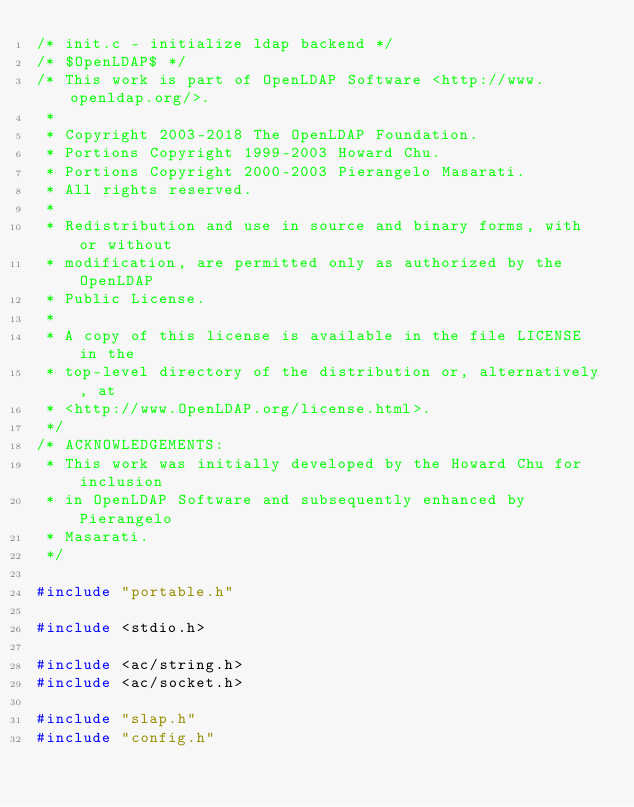Convert code to text. <code><loc_0><loc_0><loc_500><loc_500><_C_>/* init.c - initialize ldap backend */
/* $OpenLDAP$ */
/* This work is part of OpenLDAP Software <http://www.openldap.org/>.
 *
 * Copyright 2003-2018 The OpenLDAP Foundation.
 * Portions Copyright 1999-2003 Howard Chu.
 * Portions Copyright 2000-2003 Pierangelo Masarati.
 * All rights reserved.
 *
 * Redistribution and use in source and binary forms, with or without
 * modification, are permitted only as authorized by the OpenLDAP
 * Public License.
 *
 * A copy of this license is available in the file LICENSE in the
 * top-level directory of the distribution or, alternatively, at
 * <http://www.OpenLDAP.org/license.html>.
 */
/* ACKNOWLEDGEMENTS:
 * This work was initially developed by the Howard Chu for inclusion
 * in OpenLDAP Software and subsequently enhanced by Pierangelo
 * Masarati.
 */

#include "portable.h"

#include <stdio.h>

#include <ac/string.h>
#include <ac/socket.h>

#include "slap.h"
#include "config.h"</code> 